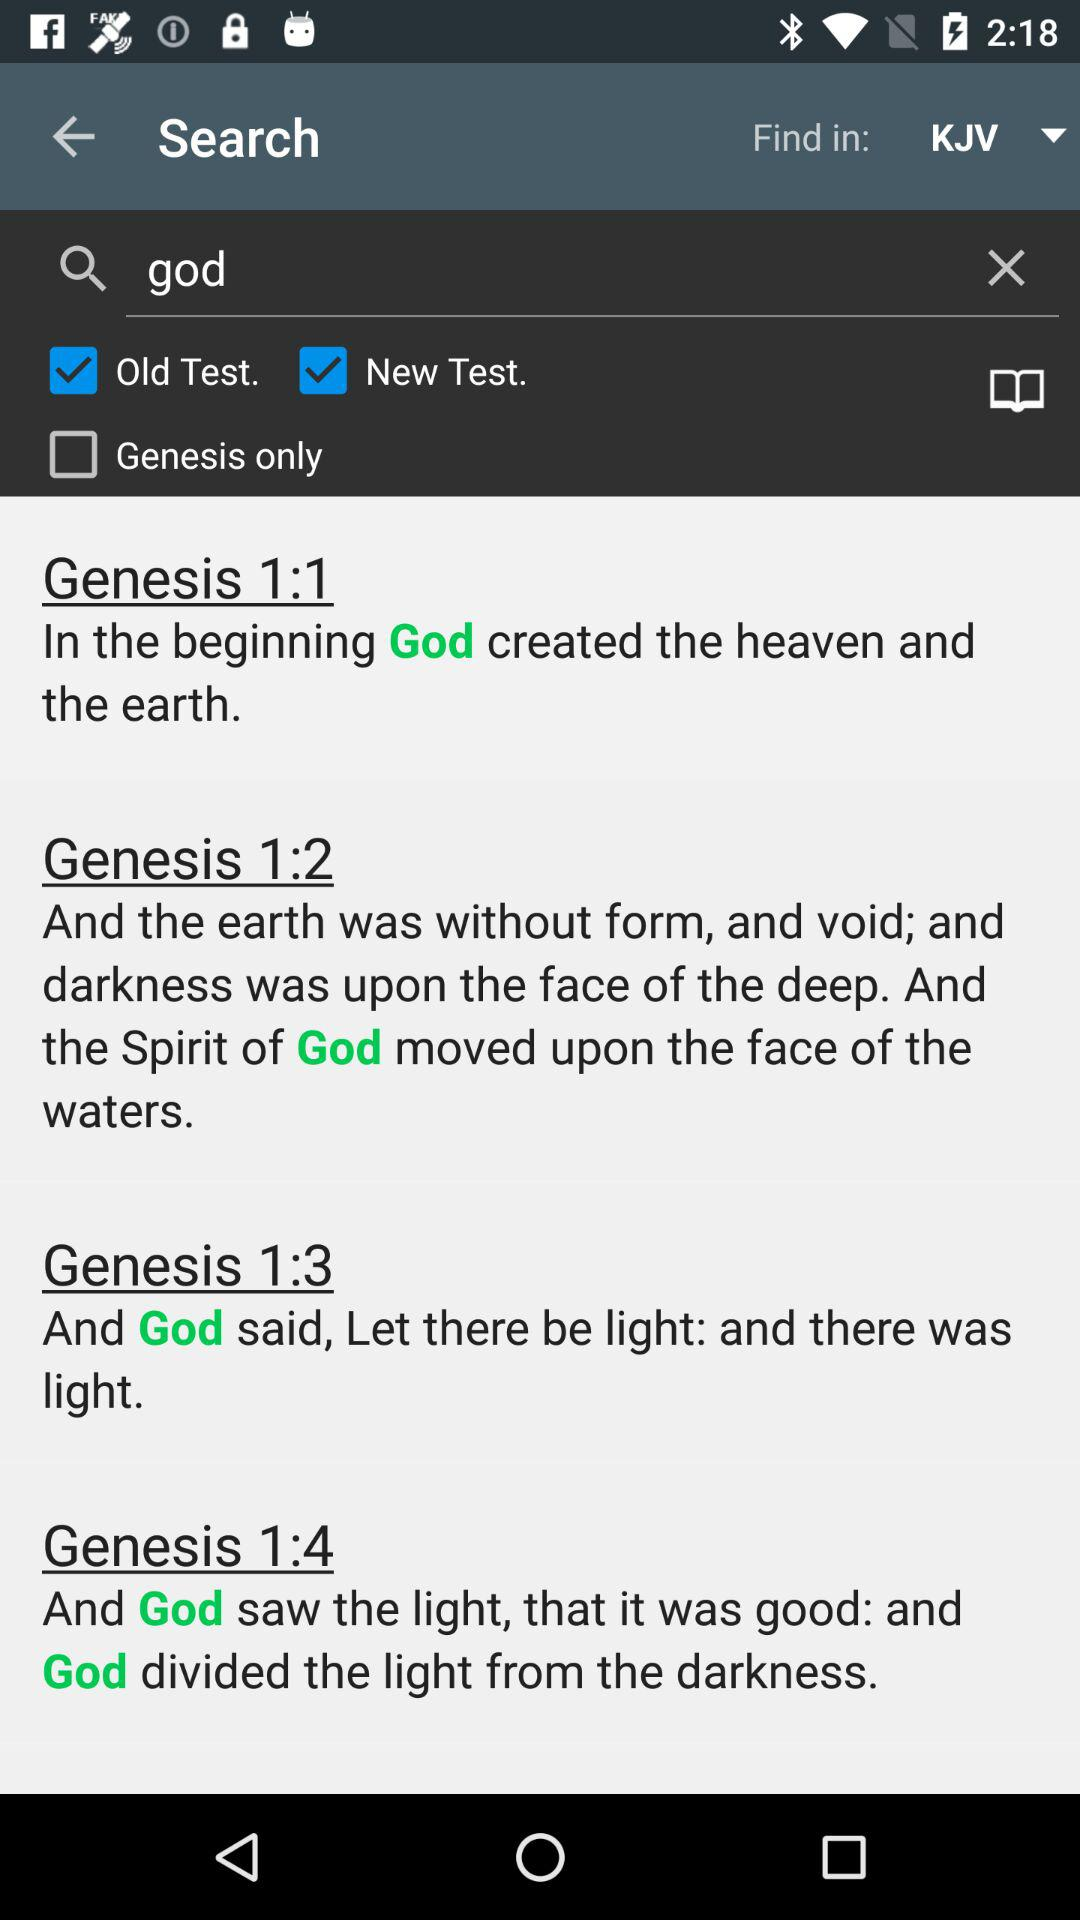Which option is selected in "Find in"? The selected option is "KJV". 